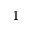Convert formula to latex. <formula><loc_0><loc_0><loc_500><loc_500>^ { 1 }</formula> 